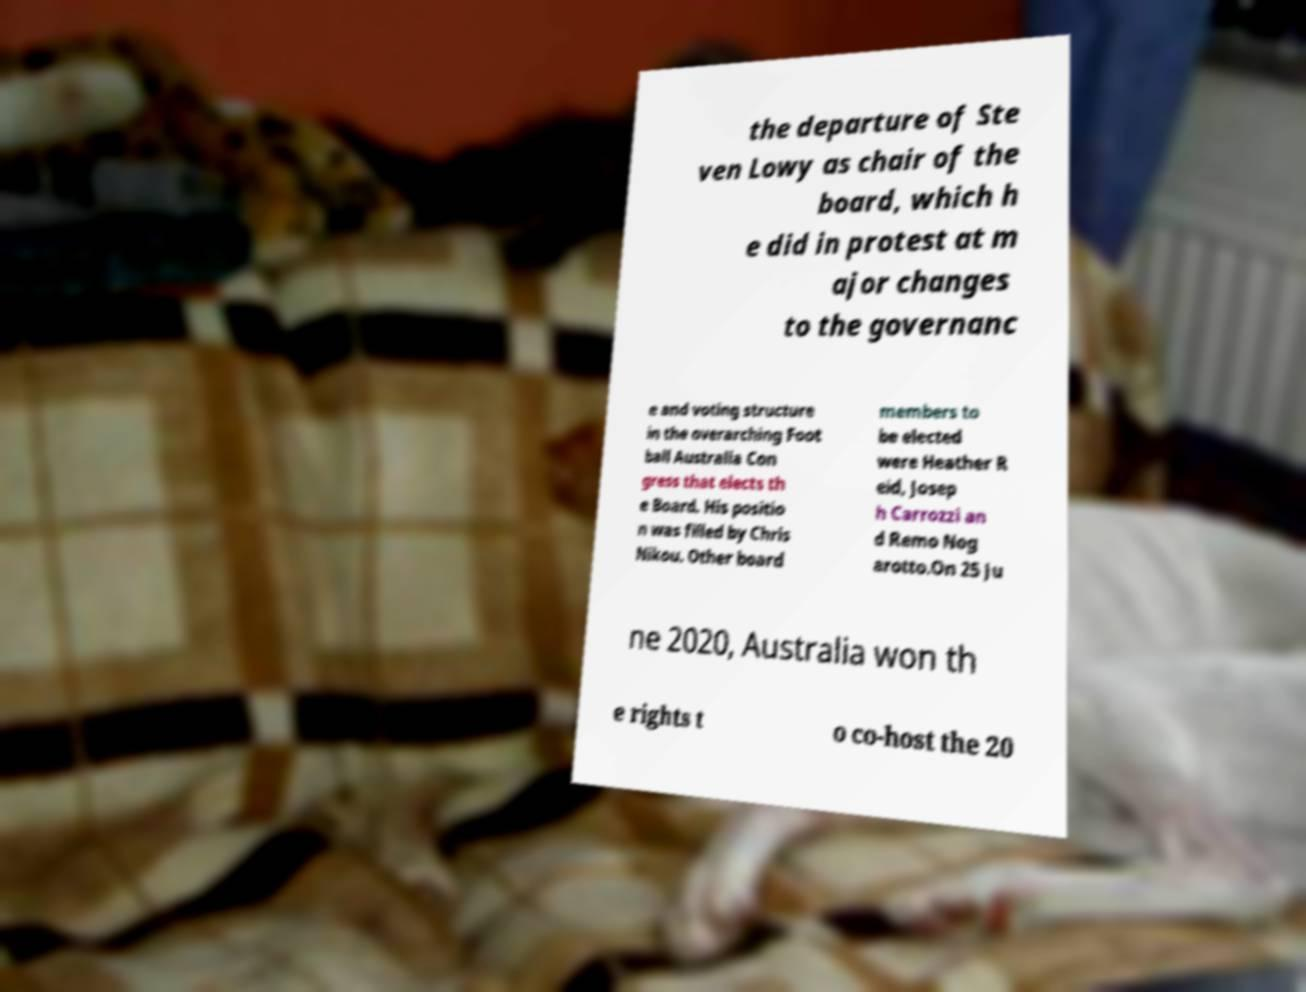Please identify and transcribe the text found in this image. the departure of Ste ven Lowy as chair of the board, which h e did in protest at m ajor changes to the governanc e and voting structure in the overarching Foot ball Australia Con gress that elects th e Board. His positio n was filled by Chris Nikou. Other board members to be elected were Heather R eid, Josep h Carrozzi an d Remo Nog arotto.On 25 Ju ne 2020, Australia won th e rights t o co-host the 20 